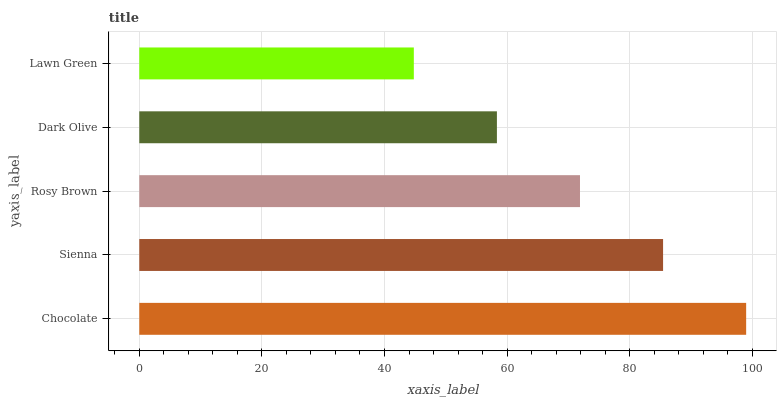Is Lawn Green the minimum?
Answer yes or no. Yes. Is Chocolate the maximum?
Answer yes or no. Yes. Is Sienna the minimum?
Answer yes or no. No. Is Sienna the maximum?
Answer yes or no. No. Is Chocolate greater than Sienna?
Answer yes or no. Yes. Is Sienna less than Chocolate?
Answer yes or no. Yes. Is Sienna greater than Chocolate?
Answer yes or no. No. Is Chocolate less than Sienna?
Answer yes or no. No. Is Rosy Brown the high median?
Answer yes or no. Yes. Is Rosy Brown the low median?
Answer yes or no. Yes. Is Dark Olive the high median?
Answer yes or no. No. Is Lawn Green the low median?
Answer yes or no. No. 